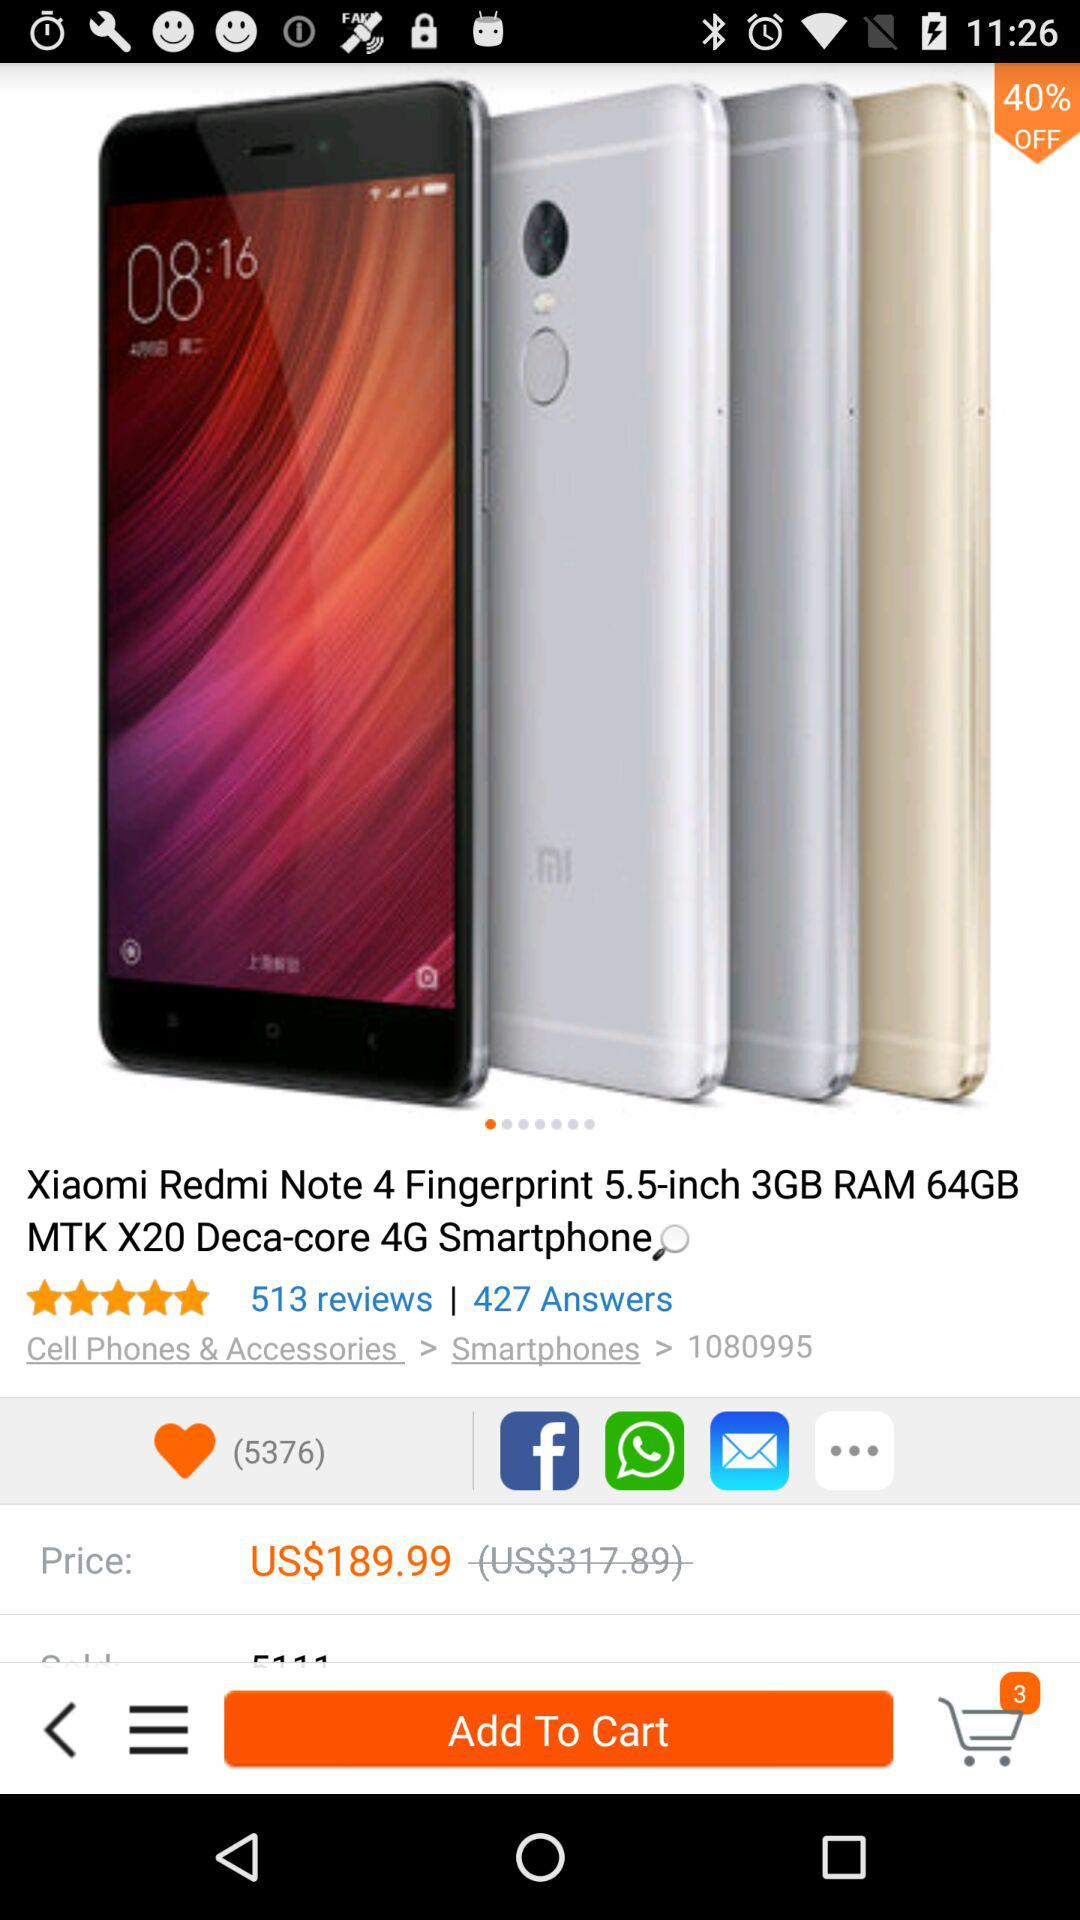What is the price of the "Xiaomi Redmi Note 4"? The price is 189.99 USD. 